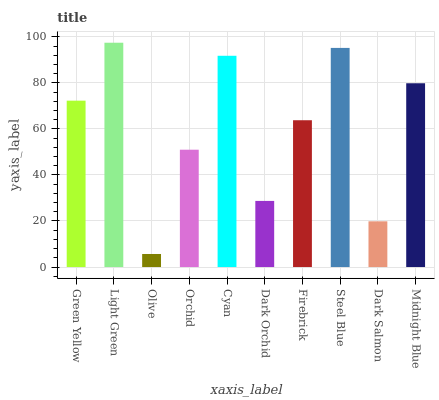Is Olive the minimum?
Answer yes or no. Yes. Is Light Green the maximum?
Answer yes or no. Yes. Is Light Green the minimum?
Answer yes or no. No. Is Olive the maximum?
Answer yes or no. No. Is Light Green greater than Olive?
Answer yes or no. Yes. Is Olive less than Light Green?
Answer yes or no. Yes. Is Olive greater than Light Green?
Answer yes or no. No. Is Light Green less than Olive?
Answer yes or no. No. Is Green Yellow the high median?
Answer yes or no. Yes. Is Firebrick the low median?
Answer yes or no. Yes. Is Firebrick the high median?
Answer yes or no. No. Is Midnight Blue the low median?
Answer yes or no. No. 